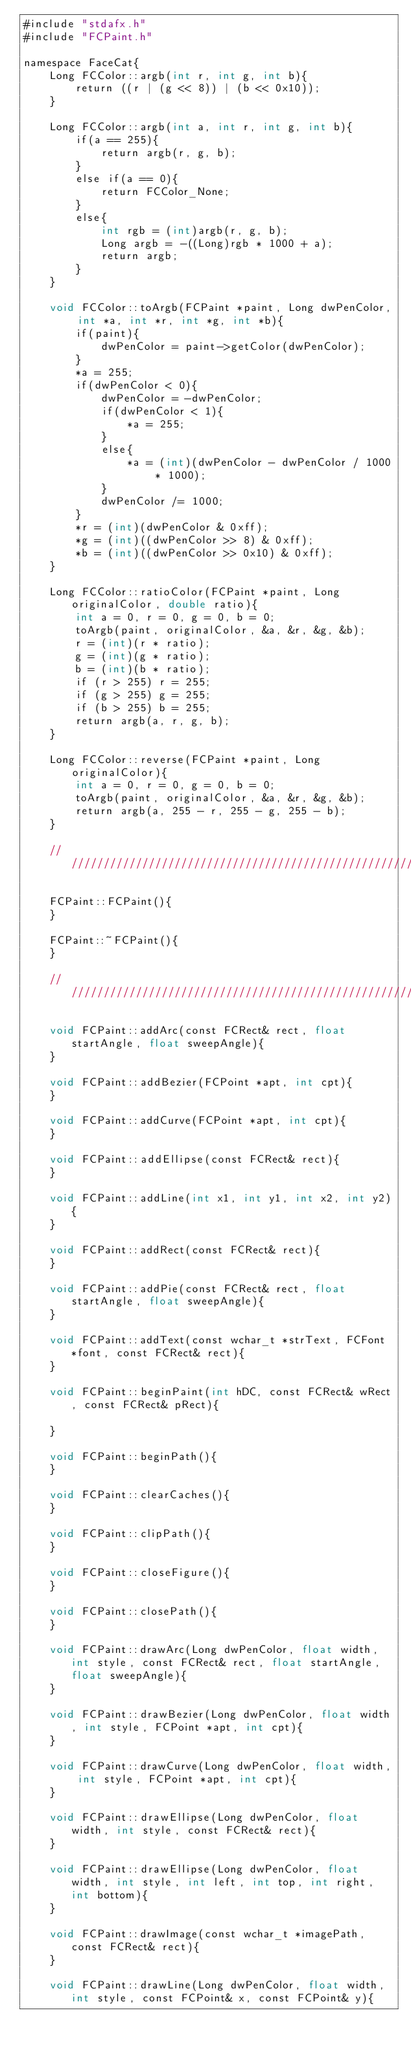<code> <loc_0><loc_0><loc_500><loc_500><_ObjectiveC_>#include "stdafx.h"
#include "FCPaint.h"

namespace FaceCat{
    Long FCColor::argb(int r, int g, int b){
        return ((r | (g << 8)) | (b << 0x10));
    }
    
    Long FCColor::argb(int a, int r, int g, int b){
        if(a == 255){
            return argb(r, g, b);
        }
        else if(a == 0){
            return FCColor_None;
        }
        else{
            int rgb = (int)argb(r, g, b);
            Long argb = -((Long)rgb * 1000 + a);
            return argb;
        }
    }
    
    void FCColor::toArgb(FCPaint *paint, Long dwPenColor, int *a, int *r, int *g, int *b){
        if(paint){
            dwPenColor = paint->getColor(dwPenColor);
        }
        *a = 255;
        if(dwPenColor < 0){
            dwPenColor = -dwPenColor;
            if(dwPenColor < 1){
                *a = 255;
            }
            else{
                *a = (int)(dwPenColor - dwPenColor / 1000 * 1000);
            }
            dwPenColor /= 1000;
        }
        *r = (int)(dwPenColor & 0xff);
        *g = (int)((dwPenColor >> 8) & 0xff);
        *b = (int)((dwPenColor >> 0x10) & 0xff);
    }
    
    Long FCColor::ratioColor(FCPaint *paint, Long originalColor, double ratio){
        int a = 0, r = 0, g = 0, b = 0;
        toArgb(paint, originalColor, &a, &r, &g, &b);
        r = (int)(r * ratio);
        g = (int)(g * ratio);
        b = (int)(b * ratio);
        if (r > 255) r = 255;
        if (g > 255) g = 255;
        if (b > 255) b = 255;
        return argb(a, r, g, b);
    }
    
    Long FCColor::reverse(FCPaint *paint, Long originalColor){
        int a = 0, r = 0, g = 0, b = 0;
        toArgb(paint, originalColor, &a, &r, &g, &b);
        return argb(a, 255 - r, 255 - g, 255 - b);
    }
    
    ///////////////////////////////////////////////////////////////////////////////////////////////////////////////////////
    
    FCPaint::FCPaint(){
    }
    
    FCPaint::~FCPaint(){
    }
    
    //////////////////////////////////////////////////////////////////////////////////////////////////////////////////////
    
    void FCPaint::addArc(const FCRect& rect, float startAngle, float sweepAngle){
    }
    
    void FCPaint::addBezier(FCPoint *apt, int cpt){
    }
    
    void FCPaint::addCurve(FCPoint *apt, int cpt){
    }
    
    void FCPaint::addEllipse(const FCRect& rect){
    }
    
    void FCPaint::addLine(int x1, int y1, int x2, int y2){
    }
    
    void FCPaint::addRect(const FCRect& rect){
    }
    
    void FCPaint::addPie(const FCRect& rect, float startAngle, float sweepAngle){
    }
    
    void FCPaint::addText(const wchar_t *strText, FCFont *font, const FCRect& rect){
    }
    
    void FCPaint::beginPaint(int hDC, const FCRect& wRect, const FCRect& pRect){
        
    }
    
    void FCPaint::beginPath(){
    }
    
    void FCPaint::clearCaches(){
    }
    
    void FCPaint::clipPath(){
    }
    
    void FCPaint::closeFigure(){
    }
    
    void FCPaint::closePath(){
    }
    
    void FCPaint::drawArc(Long dwPenColor, float width, int style, const FCRect& rect, float startAngle, float sweepAngle){
    }
    
    void FCPaint::drawBezier(Long dwPenColor, float width, int style, FCPoint *apt, int cpt){
    }
    
    void FCPaint::drawCurve(Long dwPenColor, float width, int style, FCPoint *apt, int cpt){
    }
    
    void FCPaint::drawEllipse(Long dwPenColor, float width, int style, const FCRect& rect){
    }
    
    void FCPaint::drawEllipse(Long dwPenColor, float width, int style, int left, int top, int right, int bottom){
    }
    
    void FCPaint::drawImage(const wchar_t *imagePath, const FCRect& rect){
    }
    
    void FCPaint::drawLine(Long dwPenColor, float width, int style, const FCPoint& x, const FCPoint& y){</code> 